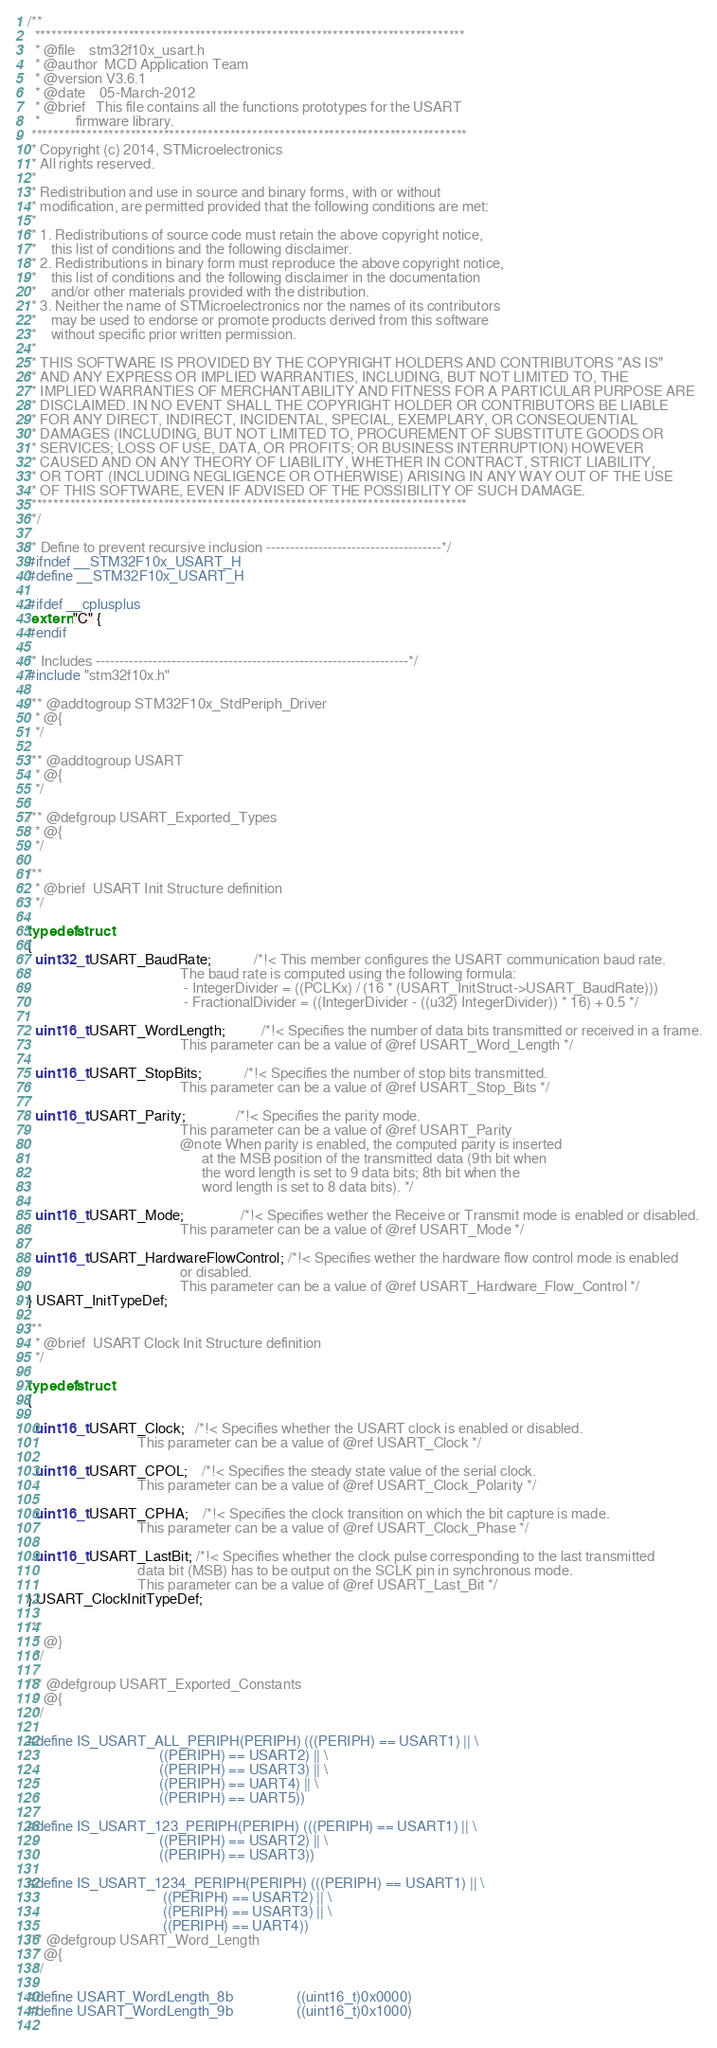<code> <loc_0><loc_0><loc_500><loc_500><_C_>/**
  ******************************************************************************
  * @file    stm32f10x_usart.h
  * @author  MCD Application Team
  * @version V3.6.1
  * @date    05-March-2012
  * @brief   This file contains all the functions prototypes for the USART 
  *          firmware library.
 *******************************************************************************
 * Copyright (c) 2014, STMicroelectronics
 * All rights reserved.
 *
 * Redistribution and use in source and binary forms, with or without
 * modification, are permitted provided that the following conditions are met:
 *
 * 1. Redistributions of source code must retain the above copyright notice,
 *    this list of conditions and the following disclaimer.
 * 2. Redistributions in binary form must reproduce the above copyright notice,
 *    this list of conditions and the following disclaimer in the documentation
 *    and/or other materials provided with the distribution.
 * 3. Neither the name of STMicroelectronics nor the names of its contributors
 *    may be used to endorse or promote products derived from this software
 *    without specific prior written permission.
 *
 * THIS SOFTWARE IS PROVIDED BY THE COPYRIGHT HOLDERS AND CONTRIBUTORS "AS IS"
 * AND ANY EXPRESS OR IMPLIED WARRANTIES, INCLUDING, BUT NOT LIMITED TO, THE
 * IMPLIED WARRANTIES OF MERCHANTABILITY AND FITNESS FOR A PARTICULAR PURPOSE ARE
 * DISCLAIMED. IN NO EVENT SHALL THE COPYRIGHT HOLDER OR CONTRIBUTORS BE LIABLE
 * FOR ANY DIRECT, INDIRECT, INCIDENTAL, SPECIAL, EXEMPLARY, OR CONSEQUENTIAL
 * DAMAGES (INCLUDING, BUT NOT LIMITED TO, PROCUREMENT OF SUBSTITUTE GOODS OR
 * SERVICES; LOSS OF USE, DATA, OR PROFITS; OR BUSINESS INTERRUPTION) HOWEVER
 * CAUSED AND ON ANY THEORY OF LIABILITY, WHETHER IN CONTRACT, STRICT LIABILITY,
 * OR TORT (INCLUDING NEGLIGENCE OR OTHERWISE) ARISING IN ANY WAY OUT OF THE USE
 * OF THIS SOFTWARE, EVEN IF ADVISED OF THE POSSIBILITY OF SUCH DAMAGE.
 *******************************************************************************
 */

/* Define to prevent recursive inclusion -------------------------------------*/
#ifndef __STM32F10x_USART_H
#define __STM32F10x_USART_H

#ifdef __cplusplus
 extern "C" {
#endif

/* Includes ------------------------------------------------------------------*/
#include "stm32f10x.h"

/** @addtogroup STM32F10x_StdPeriph_Driver
  * @{
  */

/** @addtogroup USART
  * @{
  */ 

/** @defgroup USART_Exported_Types
  * @{
  */ 

/** 
  * @brief  USART Init Structure definition  
  */ 
  
typedef struct
{
  uint32_t USART_BaudRate;            /*!< This member configures the USART communication baud rate.
                                           The baud rate is computed using the following formula:
                                            - IntegerDivider = ((PCLKx) / (16 * (USART_InitStruct->USART_BaudRate)))
                                            - FractionalDivider = ((IntegerDivider - ((u32) IntegerDivider)) * 16) + 0.5 */

  uint16_t USART_WordLength;          /*!< Specifies the number of data bits transmitted or received in a frame.
                                           This parameter can be a value of @ref USART_Word_Length */

  uint16_t USART_StopBits;            /*!< Specifies the number of stop bits transmitted.
                                           This parameter can be a value of @ref USART_Stop_Bits */

  uint16_t USART_Parity;              /*!< Specifies the parity mode.
                                           This parameter can be a value of @ref USART_Parity
                                           @note When parity is enabled, the computed parity is inserted
                                                 at the MSB position of the transmitted data (9th bit when
                                                 the word length is set to 9 data bits; 8th bit when the
                                                 word length is set to 8 data bits). */
 
  uint16_t USART_Mode;                /*!< Specifies wether the Receive or Transmit mode is enabled or disabled.
                                           This parameter can be a value of @ref USART_Mode */

  uint16_t USART_HardwareFlowControl; /*!< Specifies wether the hardware flow control mode is enabled
                                           or disabled.
                                           This parameter can be a value of @ref USART_Hardware_Flow_Control */
} USART_InitTypeDef;

/** 
  * @brief  USART Clock Init Structure definition  
  */ 
  
typedef struct
{

  uint16_t USART_Clock;   /*!< Specifies whether the USART clock is enabled or disabled.
                               This parameter can be a value of @ref USART_Clock */

  uint16_t USART_CPOL;    /*!< Specifies the steady state value of the serial clock.
                               This parameter can be a value of @ref USART_Clock_Polarity */

  uint16_t USART_CPHA;    /*!< Specifies the clock transition on which the bit capture is made.
                               This parameter can be a value of @ref USART_Clock_Phase */

  uint16_t USART_LastBit; /*!< Specifies whether the clock pulse corresponding to the last transmitted
                               data bit (MSB) has to be output on the SCLK pin in synchronous mode.
                               This parameter can be a value of @ref USART_Last_Bit */
} USART_ClockInitTypeDef;

/**
  * @}
  */ 

/** @defgroup USART_Exported_Constants
  * @{
  */ 
  
#define IS_USART_ALL_PERIPH(PERIPH) (((PERIPH) == USART1) || \
                                     ((PERIPH) == USART2) || \
                                     ((PERIPH) == USART3) || \
                                     ((PERIPH) == UART4) || \
                                     ((PERIPH) == UART5))

#define IS_USART_123_PERIPH(PERIPH) (((PERIPH) == USART1) || \
                                     ((PERIPH) == USART2) || \
                                     ((PERIPH) == USART3))

#define IS_USART_1234_PERIPH(PERIPH) (((PERIPH) == USART1) || \
                                      ((PERIPH) == USART2) || \
                                      ((PERIPH) == USART3) || \
                                      ((PERIPH) == UART4))
/** @defgroup USART_Word_Length 
  * @{
  */ 
  
#define USART_WordLength_8b                  ((uint16_t)0x0000)
#define USART_WordLength_9b                  ((uint16_t)0x1000)
                                    </code> 